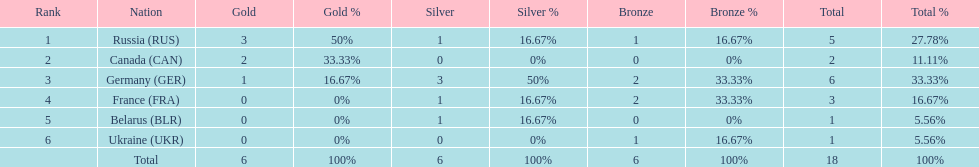What country had the most medals total at the the 1994 winter olympics biathlon? Germany (GER). 